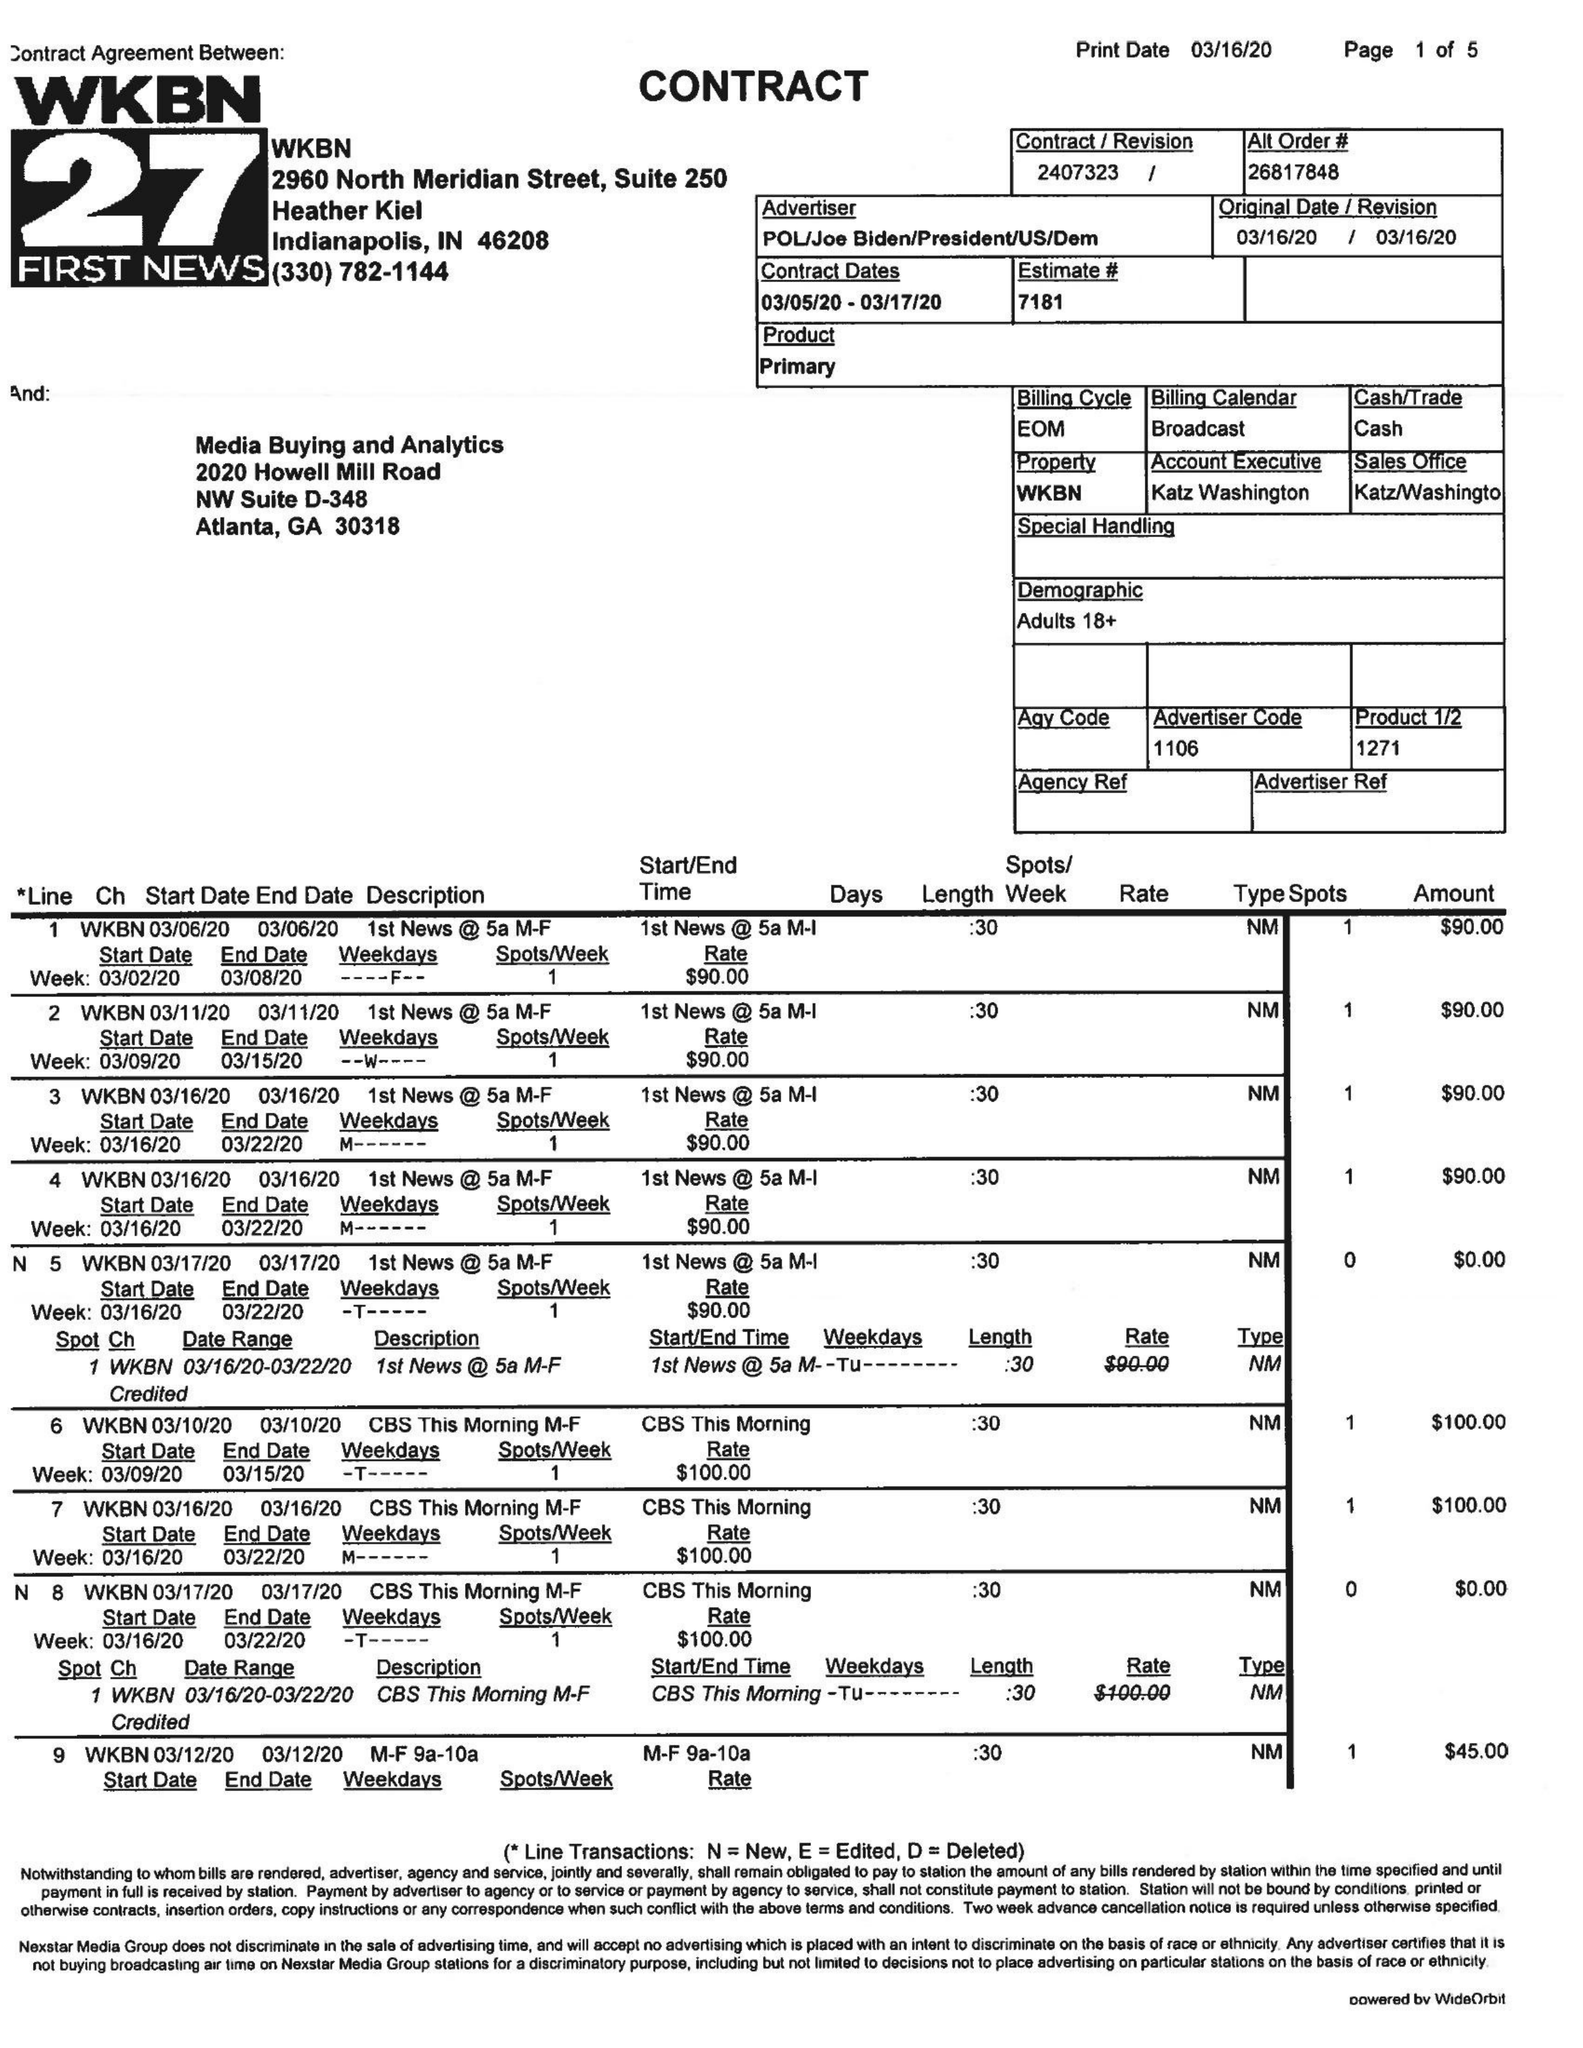What is the value for the gross_amount?
Answer the question using a single word or phrase. 9000.00 